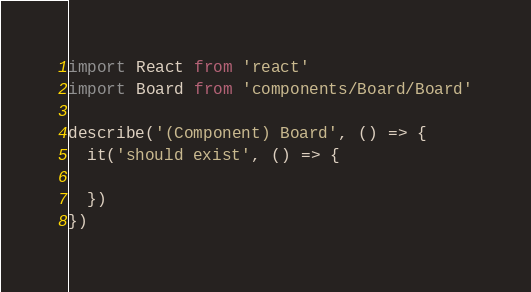<code> <loc_0><loc_0><loc_500><loc_500><_JavaScript_>import React from 'react'
import Board from 'components/Board/Board'

describe('(Component) Board', () => {
  it('should exist', () => {

  })
})
</code> 